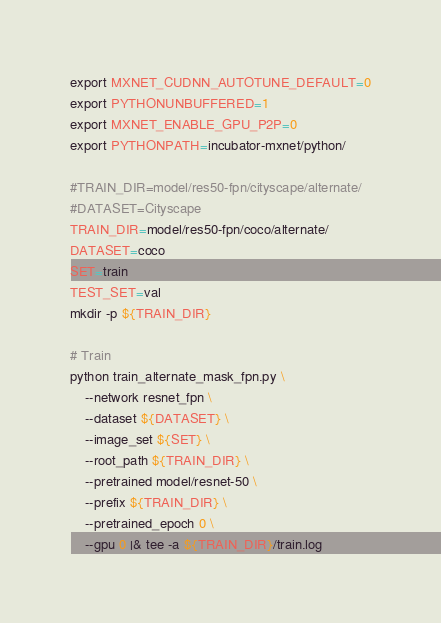<code> <loc_0><loc_0><loc_500><loc_500><_Bash_>export MXNET_CUDNN_AUTOTUNE_DEFAULT=0
export PYTHONUNBUFFERED=1
export MXNET_ENABLE_GPU_P2P=0
export PYTHONPATH=incubator-mxnet/python/

#TRAIN_DIR=model/res50-fpn/cityscape/alternate/
#DATASET=Cityscape
TRAIN_DIR=model/res50-fpn/coco/alternate/
DATASET=coco
SET=train
TEST_SET=val
mkdir -p ${TRAIN_DIR}

# Train
python train_alternate_mask_fpn.py \
    --network resnet_fpn \
    --dataset ${DATASET} \
    --image_set ${SET} \
    --root_path ${TRAIN_DIR} \
    --pretrained model/resnet-50 \
    --prefix ${TRAIN_DIR} \
    --pretrained_epoch 0 \
    --gpu 0 |& tee -a ${TRAIN_DIR}/train.log

</code> 